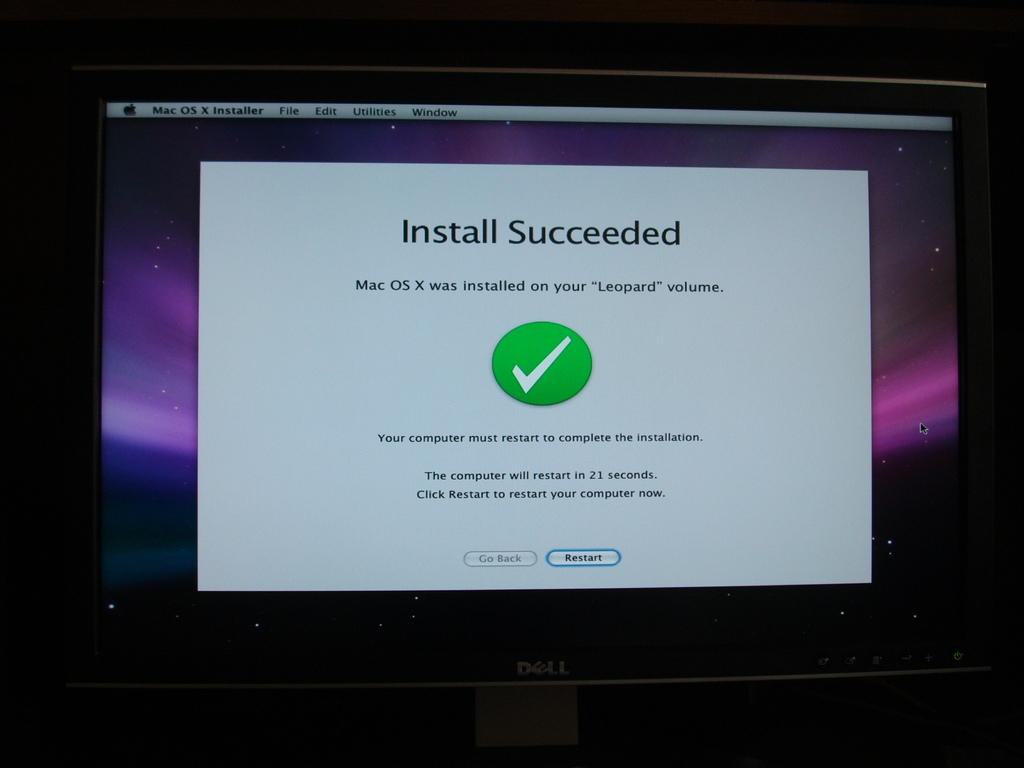<image>
Create a compact narrative representing the image presented. Dell computer monitor letting the user know the Install Succeeded. 